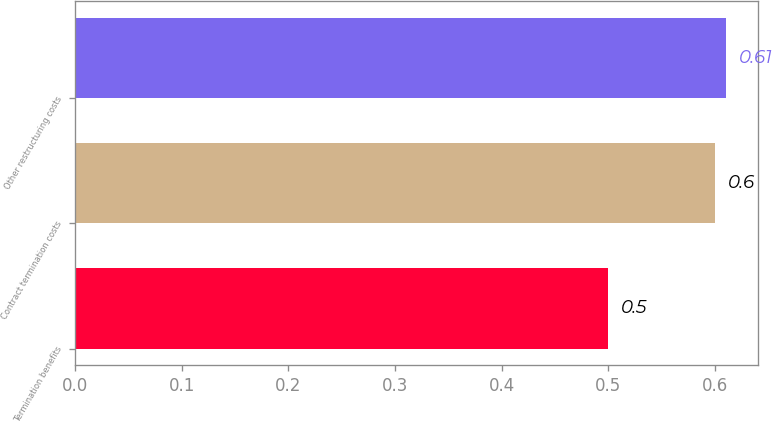Convert chart to OTSL. <chart><loc_0><loc_0><loc_500><loc_500><bar_chart><fcel>Termination benefits<fcel>Contract termination costs<fcel>Other restructuring costs<nl><fcel>0.5<fcel>0.6<fcel>0.61<nl></chart> 